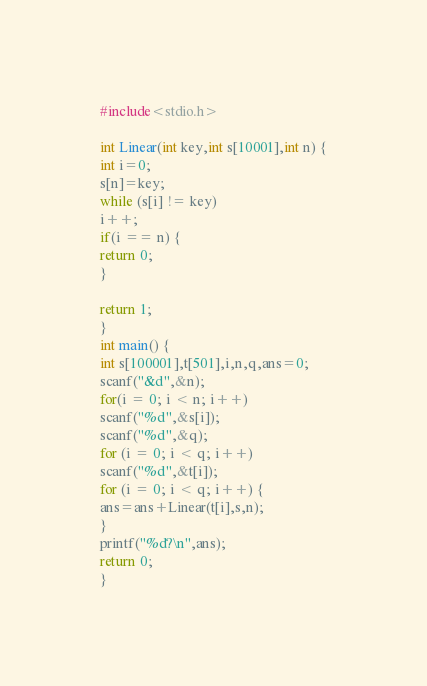Convert code to text. <code><loc_0><loc_0><loc_500><loc_500><_C_>#include<stdio.h>

int Linear(int key,int s[10001],int n) {
int i=0;
s[n]=key;
while (s[i] != key) 
i++;
if(i == n) {
return 0;
}

return 1;
}
int main() {
int s[100001],t[501],i,n,q,ans=0;
scanf("&d",&n);
for(i = 0; i < n; i++)
scanf("%d",&s[i]);
scanf("%d",&q);
for (i = 0; i < q; i++)
scanf("%d",&t[i]);
for (i = 0; i < q; i++) {
ans=ans+Linear(t[i],s,n);
}
printf("%d?\n",ans);
return 0;
}</code> 